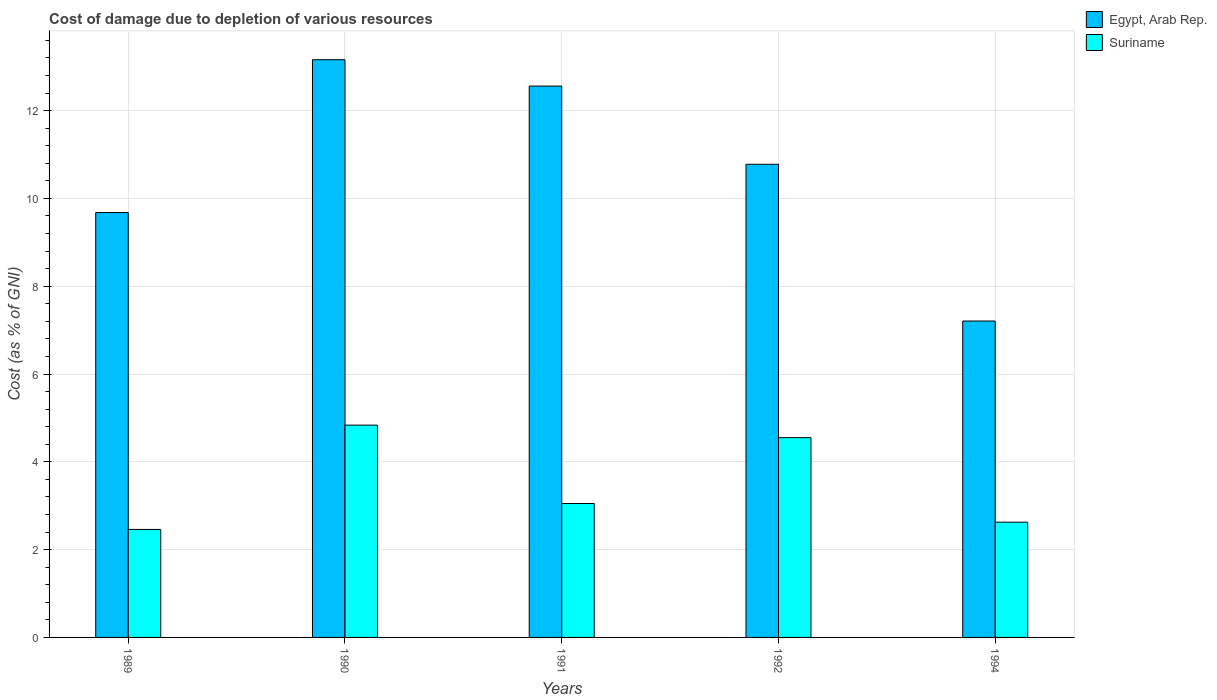How many different coloured bars are there?
Offer a very short reply. 2. Are the number of bars on each tick of the X-axis equal?
Provide a short and direct response. Yes. How many bars are there on the 2nd tick from the left?
Give a very brief answer. 2. In how many cases, is the number of bars for a given year not equal to the number of legend labels?
Give a very brief answer. 0. What is the cost of damage caused due to the depletion of various resources in Suriname in 1992?
Provide a short and direct response. 4.55. Across all years, what is the maximum cost of damage caused due to the depletion of various resources in Egypt, Arab Rep.?
Give a very brief answer. 13.16. Across all years, what is the minimum cost of damage caused due to the depletion of various resources in Egypt, Arab Rep.?
Offer a terse response. 7.21. What is the total cost of damage caused due to the depletion of various resources in Egypt, Arab Rep. in the graph?
Your answer should be compact. 53.38. What is the difference between the cost of damage caused due to the depletion of various resources in Suriname in 1989 and that in 1990?
Ensure brevity in your answer.  -2.38. What is the difference between the cost of damage caused due to the depletion of various resources in Suriname in 1989 and the cost of damage caused due to the depletion of various resources in Egypt, Arab Rep. in 1991?
Give a very brief answer. -10.1. What is the average cost of damage caused due to the depletion of various resources in Egypt, Arab Rep. per year?
Offer a terse response. 10.68. In the year 1989, what is the difference between the cost of damage caused due to the depletion of various resources in Egypt, Arab Rep. and cost of damage caused due to the depletion of various resources in Suriname?
Your response must be concise. 7.22. What is the ratio of the cost of damage caused due to the depletion of various resources in Suriname in 1992 to that in 1994?
Your answer should be compact. 1.73. Is the cost of damage caused due to the depletion of various resources in Suriname in 1989 less than that in 1991?
Your response must be concise. Yes. What is the difference between the highest and the second highest cost of damage caused due to the depletion of various resources in Egypt, Arab Rep.?
Your response must be concise. 0.6. What is the difference between the highest and the lowest cost of damage caused due to the depletion of various resources in Suriname?
Ensure brevity in your answer.  2.38. In how many years, is the cost of damage caused due to the depletion of various resources in Suriname greater than the average cost of damage caused due to the depletion of various resources in Suriname taken over all years?
Ensure brevity in your answer.  2. Is the sum of the cost of damage caused due to the depletion of various resources in Suriname in 1989 and 1992 greater than the maximum cost of damage caused due to the depletion of various resources in Egypt, Arab Rep. across all years?
Your response must be concise. No. What does the 2nd bar from the left in 1991 represents?
Your answer should be very brief. Suriname. What does the 1st bar from the right in 1994 represents?
Provide a succinct answer. Suriname. Where does the legend appear in the graph?
Ensure brevity in your answer.  Top right. What is the title of the graph?
Ensure brevity in your answer.  Cost of damage due to depletion of various resources. What is the label or title of the X-axis?
Your response must be concise. Years. What is the label or title of the Y-axis?
Provide a short and direct response. Cost (as % of GNI). What is the Cost (as % of GNI) in Egypt, Arab Rep. in 1989?
Offer a terse response. 9.68. What is the Cost (as % of GNI) in Suriname in 1989?
Make the answer very short. 2.46. What is the Cost (as % of GNI) of Egypt, Arab Rep. in 1990?
Ensure brevity in your answer.  13.16. What is the Cost (as % of GNI) in Suriname in 1990?
Your response must be concise. 4.84. What is the Cost (as % of GNI) in Egypt, Arab Rep. in 1991?
Provide a succinct answer. 12.56. What is the Cost (as % of GNI) in Suriname in 1991?
Provide a succinct answer. 3.05. What is the Cost (as % of GNI) of Egypt, Arab Rep. in 1992?
Provide a succinct answer. 10.78. What is the Cost (as % of GNI) in Suriname in 1992?
Provide a short and direct response. 4.55. What is the Cost (as % of GNI) in Egypt, Arab Rep. in 1994?
Ensure brevity in your answer.  7.21. What is the Cost (as % of GNI) in Suriname in 1994?
Make the answer very short. 2.62. Across all years, what is the maximum Cost (as % of GNI) of Egypt, Arab Rep.?
Offer a terse response. 13.16. Across all years, what is the maximum Cost (as % of GNI) of Suriname?
Provide a short and direct response. 4.84. Across all years, what is the minimum Cost (as % of GNI) in Egypt, Arab Rep.?
Your answer should be compact. 7.21. Across all years, what is the minimum Cost (as % of GNI) of Suriname?
Give a very brief answer. 2.46. What is the total Cost (as % of GNI) of Egypt, Arab Rep. in the graph?
Make the answer very short. 53.38. What is the total Cost (as % of GNI) in Suriname in the graph?
Keep it short and to the point. 17.52. What is the difference between the Cost (as % of GNI) of Egypt, Arab Rep. in 1989 and that in 1990?
Your response must be concise. -3.48. What is the difference between the Cost (as % of GNI) of Suriname in 1989 and that in 1990?
Give a very brief answer. -2.38. What is the difference between the Cost (as % of GNI) in Egypt, Arab Rep. in 1989 and that in 1991?
Ensure brevity in your answer.  -2.88. What is the difference between the Cost (as % of GNI) in Suriname in 1989 and that in 1991?
Your answer should be very brief. -0.59. What is the difference between the Cost (as % of GNI) of Egypt, Arab Rep. in 1989 and that in 1992?
Offer a terse response. -1.1. What is the difference between the Cost (as % of GNI) of Suriname in 1989 and that in 1992?
Provide a succinct answer. -2.09. What is the difference between the Cost (as % of GNI) in Egypt, Arab Rep. in 1989 and that in 1994?
Keep it short and to the point. 2.47. What is the difference between the Cost (as % of GNI) of Suriname in 1989 and that in 1994?
Give a very brief answer. -0.17. What is the difference between the Cost (as % of GNI) in Egypt, Arab Rep. in 1990 and that in 1991?
Provide a succinct answer. 0.6. What is the difference between the Cost (as % of GNI) in Suriname in 1990 and that in 1991?
Your answer should be very brief. 1.78. What is the difference between the Cost (as % of GNI) in Egypt, Arab Rep. in 1990 and that in 1992?
Provide a short and direct response. 2.38. What is the difference between the Cost (as % of GNI) of Suriname in 1990 and that in 1992?
Offer a terse response. 0.29. What is the difference between the Cost (as % of GNI) of Egypt, Arab Rep. in 1990 and that in 1994?
Your answer should be compact. 5.95. What is the difference between the Cost (as % of GNI) in Suriname in 1990 and that in 1994?
Give a very brief answer. 2.21. What is the difference between the Cost (as % of GNI) in Egypt, Arab Rep. in 1991 and that in 1992?
Provide a succinct answer. 1.78. What is the difference between the Cost (as % of GNI) in Suriname in 1991 and that in 1992?
Offer a very short reply. -1.5. What is the difference between the Cost (as % of GNI) of Egypt, Arab Rep. in 1991 and that in 1994?
Provide a short and direct response. 5.35. What is the difference between the Cost (as % of GNI) of Suriname in 1991 and that in 1994?
Ensure brevity in your answer.  0.43. What is the difference between the Cost (as % of GNI) in Egypt, Arab Rep. in 1992 and that in 1994?
Offer a very short reply. 3.57. What is the difference between the Cost (as % of GNI) in Suriname in 1992 and that in 1994?
Provide a succinct answer. 1.93. What is the difference between the Cost (as % of GNI) in Egypt, Arab Rep. in 1989 and the Cost (as % of GNI) in Suriname in 1990?
Your answer should be compact. 4.84. What is the difference between the Cost (as % of GNI) in Egypt, Arab Rep. in 1989 and the Cost (as % of GNI) in Suriname in 1991?
Ensure brevity in your answer.  6.63. What is the difference between the Cost (as % of GNI) in Egypt, Arab Rep. in 1989 and the Cost (as % of GNI) in Suriname in 1992?
Your answer should be very brief. 5.13. What is the difference between the Cost (as % of GNI) in Egypt, Arab Rep. in 1989 and the Cost (as % of GNI) in Suriname in 1994?
Offer a very short reply. 7.05. What is the difference between the Cost (as % of GNI) in Egypt, Arab Rep. in 1990 and the Cost (as % of GNI) in Suriname in 1991?
Offer a very short reply. 10.11. What is the difference between the Cost (as % of GNI) of Egypt, Arab Rep. in 1990 and the Cost (as % of GNI) of Suriname in 1992?
Provide a short and direct response. 8.61. What is the difference between the Cost (as % of GNI) in Egypt, Arab Rep. in 1990 and the Cost (as % of GNI) in Suriname in 1994?
Ensure brevity in your answer.  10.53. What is the difference between the Cost (as % of GNI) in Egypt, Arab Rep. in 1991 and the Cost (as % of GNI) in Suriname in 1992?
Your answer should be very brief. 8.01. What is the difference between the Cost (as % of GNI) of Egypt, Arab Rep. in 1991 and the Cost (as % of GNI) of Suriname in 1994?
Keep it short and to the point. 9.93. What is the difference between the Cost (as % of GNI) in Egypt, Arab Rep. in 1992 and the Cost (as % of GNI) in Suriname in 1994?
Provide a succinct answer. 8.15. What is the average Cost (as % of GNI) of Egypt, Arab Rep. per year?
Your answer should be compact. 10.68. What is the average Cost (as % of GNI) in Suriname per year?
Make the answer very short. 3.5. In the year 1989, what is the difference between the Cost (as % of GNI) of Egypt, Arab Rep. and Cost (as % of GNI) of Suriname?
Make the answer very short. 7.22. In the year 1990, what is the difference between the Cost (as % of GNI) in Egypt, Arab Rep. and Cost (as % of GNI) in Suriname?
Provide a short and direct response. 8.32. In the year 1991, what is the difference between the Cost (as % of GNI) of Egypt, Arab Rep. and Cost (as % of GNI) of Suriname?
Offer a very short reply. 9.51. In the year 1992, what is the difference between the Cost (as % of GNI) of Egypt, Arab Rep. and Cost (as % of GNI) of Suriname?
Your response must be concise. 6.23. In the year 1994, what is the difference between the Cost (as % of GNI) in Egypt, Arab Rep. and Cost (as % of GNI) in Suriname?
Offer a very short reply. 4.58. What is the ratio of the Cost (as % of GNI) of Egypt, Arab Rep. in 1989 to that in 1990?
Make the answer very short. 0.74. What is the ratio of the Cost (as % of GNI) in Suriname in 1989 to that in 1990?
Your answer should be very brief. 0.51. What is the ratio of the Cost (as % of GNI) in Egypt, Arab Rep. in 1989 to that in 1991?
Your answer should be very brief. 0.77. What is the ratio of the Cost (as % of GNI) of Suriname in 1989 to that in 1991?
Provide a succinct answer. 0.81. What is the ratio of the Cost (as % of GNI) in Egypt, Arab Rep. in 1989 to that in 1992?
Offer a very short reply. 0.9. What is the ratio of the Cost (as % of GNI) of Suriname in 1989 to that in 1992?
Offer a very short reply. 0.54. What is the ratio of the Cost (as % of GNI) of Egypt, Arab Rep. in 1989 to that in 1994?
Make the answer very short. 1.34. What is the ratio of the Cost (as % of GNI) in Suriname in 1989 to that in 1994?
Your answer should be very brief. 0.94. What is the ratio of the Cost (as % of GNI) in Egypt, Arab Rep. in 1990 to that in 1991?
Offer a very short reply. 1.05. What is the ratio of the Cost (as % of GNI) in Suriname in 1990 to that in 1991?
Your answer should be compact. 1.58. What is the ratio of the Cost (as % of GNI) of Egypt, Arab Rep. in 1990 to that in 1992?
Offer a terse response. 1.22. What is the ratio of the Cost (as % of GNI) in Suriname in 1990 to that in 1992?
Keep it short and to the point. 1.06. What is the ratio of the Cost (as % of GNI) in Egypt, Arab Rep. in 1990 to that in 1994?
Offer a terse response. 1.83. What is the ratio of the Cost (as % of GNI) in Suriname in 1990 to that in 1994?
Your answer should be compact. 1.84. What is the ratio of the Cost (as % of GNI) of Egypt, Arab Rep. in 1991 to that in 1992?
Offer a terse response. 1.17. What is the ratio of the Cost (as % of GNI) of Suriname in 1991 to that in 1992?
Your response must be concise. 0.67. What is the ratio of the Cost (as % of GNI) in Egypt, Arab Rep. in 1991 to that in 1994?
Your answer should be very brief. 1.74. What is the ratio of the Cost (as % of GNI) in Suriname in 1991 to that in 1994?
Make the answer very short. 1.16. What is the ratio of the Cost (as % of GNI) of Egypt, Arab Rep. in 1992 to that in 1994?
Your response must be concise. 1.5. What is the ratio of the Cost (as % of GNI) of Suriname in 1992 to that in 1994?
Keep it short and to the point. 1.73. What is the difference between the highest and the second highest Cost (as % of GNI) of Egypt, Arab Rep.?
Make the answer very short. 0.6. What is the difference between the highest and the second highest Cost (as % of GNI) of Suriname?
Give a very brief answer. 0.29. What is the difference between the highest and the lowest Cost (as % of GNI) of Egypt, Arab Rep.?
Keep it short and to the point. 5.95. What is the difference between the highest and the lowest Cost (as % of GNI) of Suriname?
Provide a succinct answer. 2.38. 